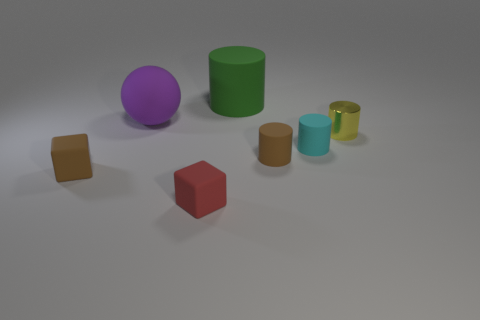What number of shiny cylinders are there?
Your response must be concise. 1. There is a tiny thing behind the small cyan rubber cylinder; what is it made of?
Ensure brevity in your answer.  Metal. Are there any brown rubber things on the left side of the brown cylinder?
Your answer should be very brief. Yes. Is the green rubber cylinder the same size as the red matte thing?
Make the answer very short. No. How many cylinders have the same material as the big purple sphere?
Provide a short and direct response. 3. There is a brown matte object that is on the right side of the large matte object that is on the left side of the red block; what size is it?
Your response must be concise. Small. What is the color of the tiny thing that is both behind the small brown rubber cylinder and to the left of the metal cylinder?
Give a very brief answer. Cyan. Is the shape of the small red matte thing the same as the small yellow thing?
Your response must be concise. No. The tiny brown object to the left of the brown rubber object that is to the right of the tiny brown cube is what shape?
Offer a very short reply. Cube. There is a green thing; is it the same shape as the tiny brown object right of the red matte block?
Provide a short and direct response. Yes. 